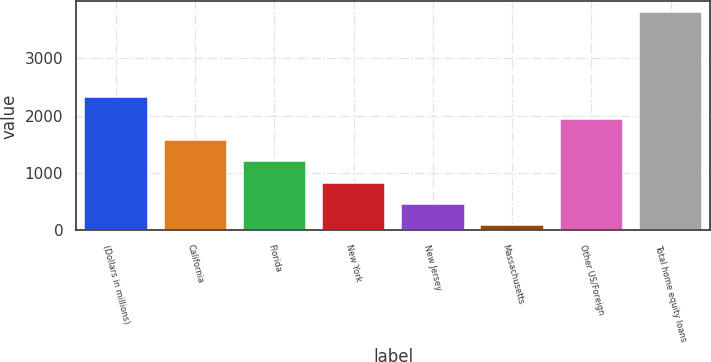Convert chart. <chart><loc_0><loc_0><loc_500><loc_500><bar_chart><fcel>(Dollars in millions)<fcel>California<fcel>Florida<fcel>New York<fcel>New Jersey<fcel>Massachusetts<fcel>Other US/Foreign<fcel>Total home equity loans<nl><fcel>2318.4<fcel>1575.6<fcel>1204.2<fcel>832.8<fcel>461.4<fcel>90<fcel>1947<fcel>3804<nl></chart> 